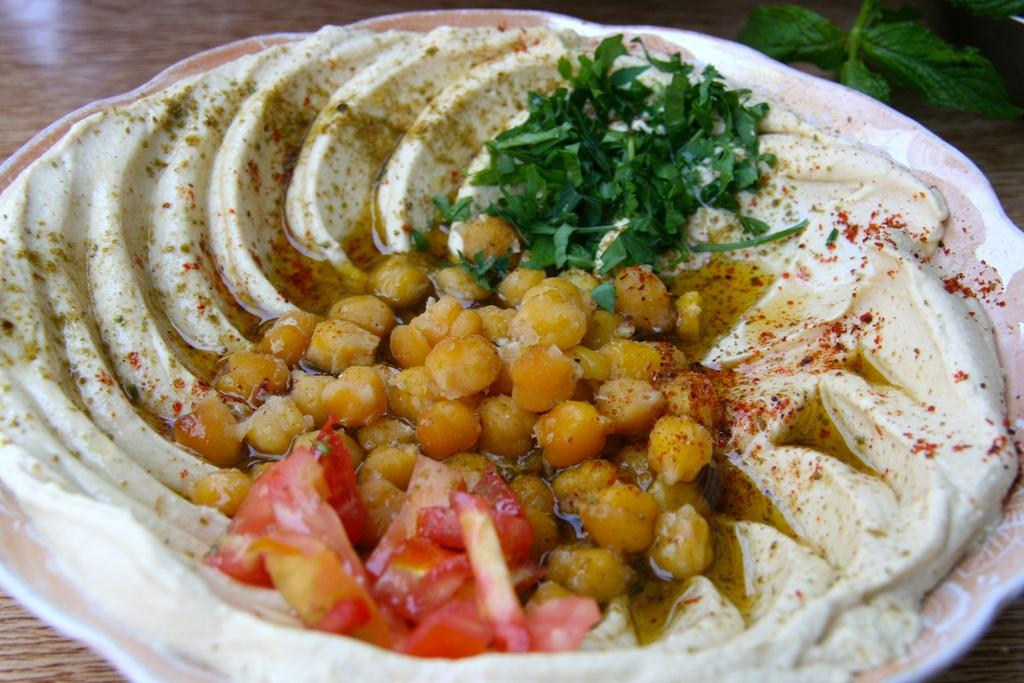What type of furniture is present in the image? There is a table in the image. What is on top of the table? There is a leaf and a plate on the table. What is inside the plate? There is a dish in the plate. How many frogs can be seen jumping on the table in the image? There are no frogs present in the image; it only features a table, a leaf, a plate, and a dish. 